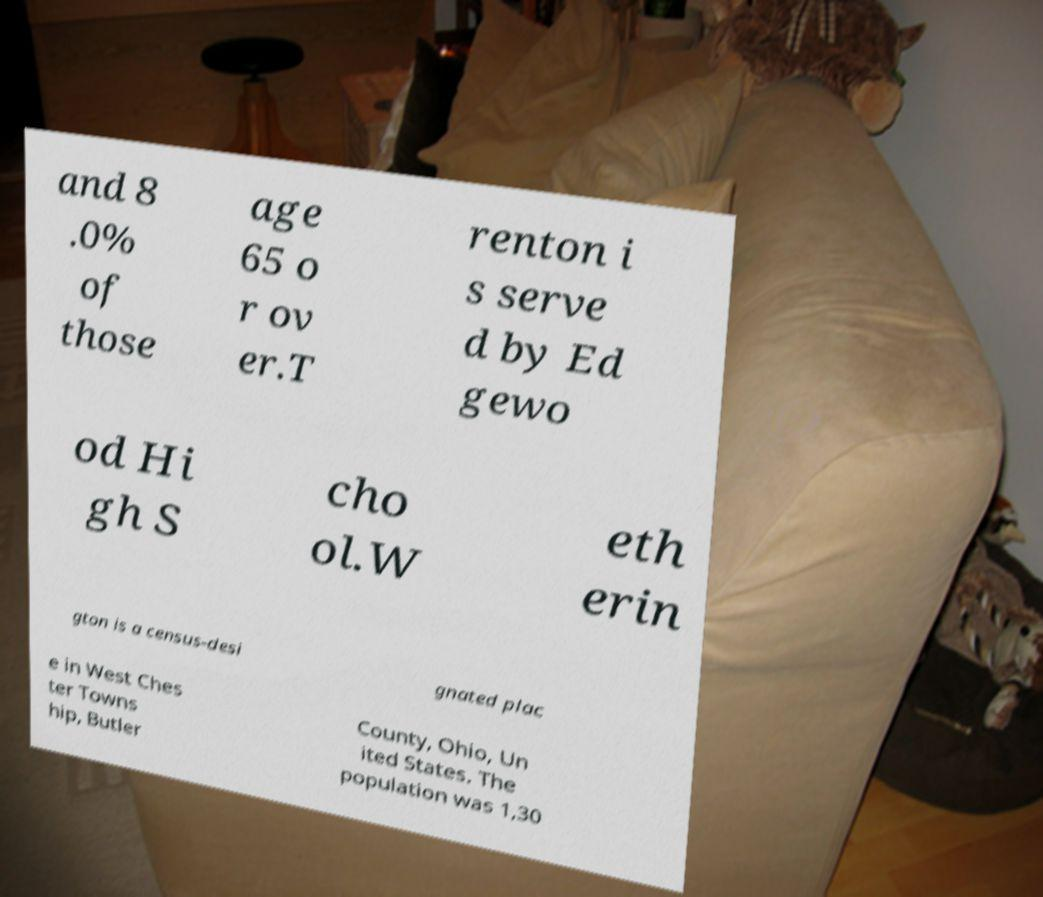I need the written content from this picture converted into text. Can you do that? and 8 .0% of those age 65 o r ov er.T renton i s serve d by Ed gewo od Hi gh S cho ol.W eth erin gton is a census-desi gnated plac e in West Ches ter Towns hip, Butler County, Ohio, Un ited States. The population was 1,30 